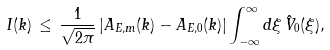Convert formula to latex. <formula><loc_0><loc_0><loc_500><loc_500>I ( k ) \, \leq \, \frac { 1 } { \sqrt { 2 \pi } } \, | A _ { E , m } ( k ) - A _ { E , 0 } ( k ) | \int _ { - \infty } ^ { \infty } d \xi \, \hat { V } _ { 0 } ( \xi ) ,</formula> 